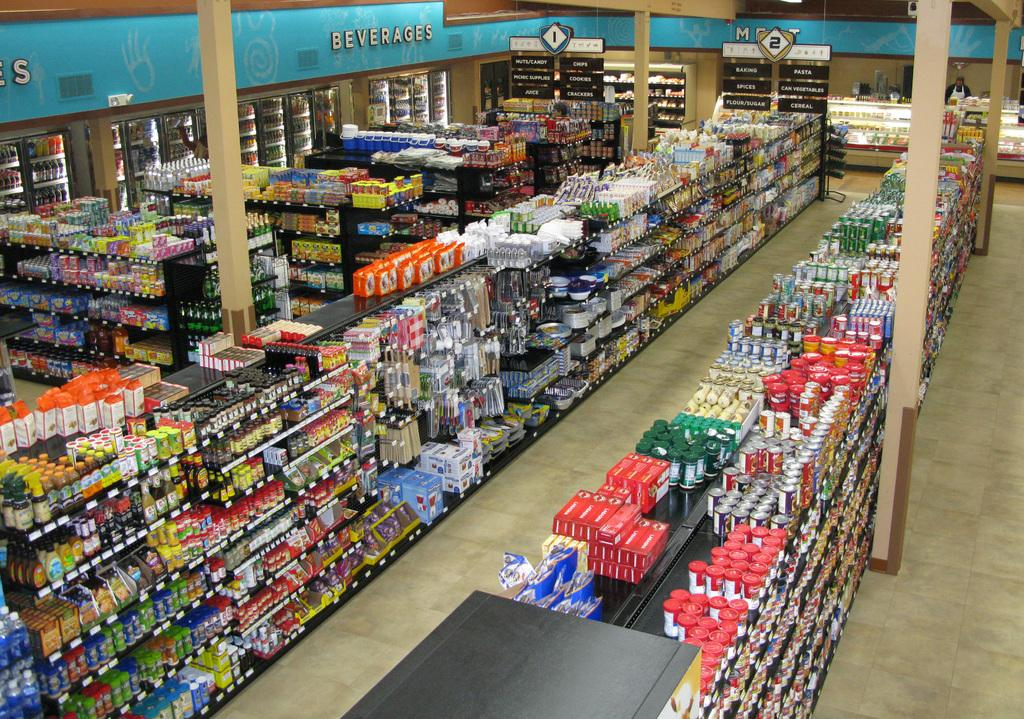Where was the image taken? The image was taken inside a store. What can be seen on the racks in the store? There are products on the racks in the store. What is the condition of the floor in the store? There are products on the floor in the store. What can be seen on the pillars in the store? There are products on the pillars in the store. What type of products can be found in the fridge in the store? There are beverages in the fridge in the store. How are the different sections of the store identified? There are name boards hanging from the ceiling in the store. Can you see any crackers being eaten by ducks in the image? There are no crackers or ducks present in the image. Is there anyone trying to walk on the ceiling in the image? There is no one attempting to walk on the ceiling in the image. 